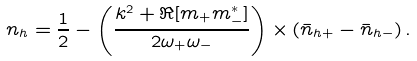Convert formula to latex. <formula><loc_0><loc_0><loc_500><loc_500>n _ { h } = \frac { 1 } { 2 } - \left ( \frac { k ^ { 2 } + \Re [ m _ { + } m _ { - } ^ { * } ] } { 2 \omega _ { + } \omega _ { - } } \right ) \times ( \bar { n } _ { h + } - \bar { n } _ { h - } ) \, .</formula> 